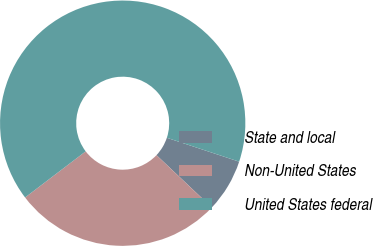Convert chart. <chart><loc_0><loc_0><loc_500><loc_500><pie_chart><fcel>State and local<fcel>Non-United States<fcel>United States federal<nl><fcel>6.98%<fcel>27.59%<fcel>65.44%<nl></chart> 